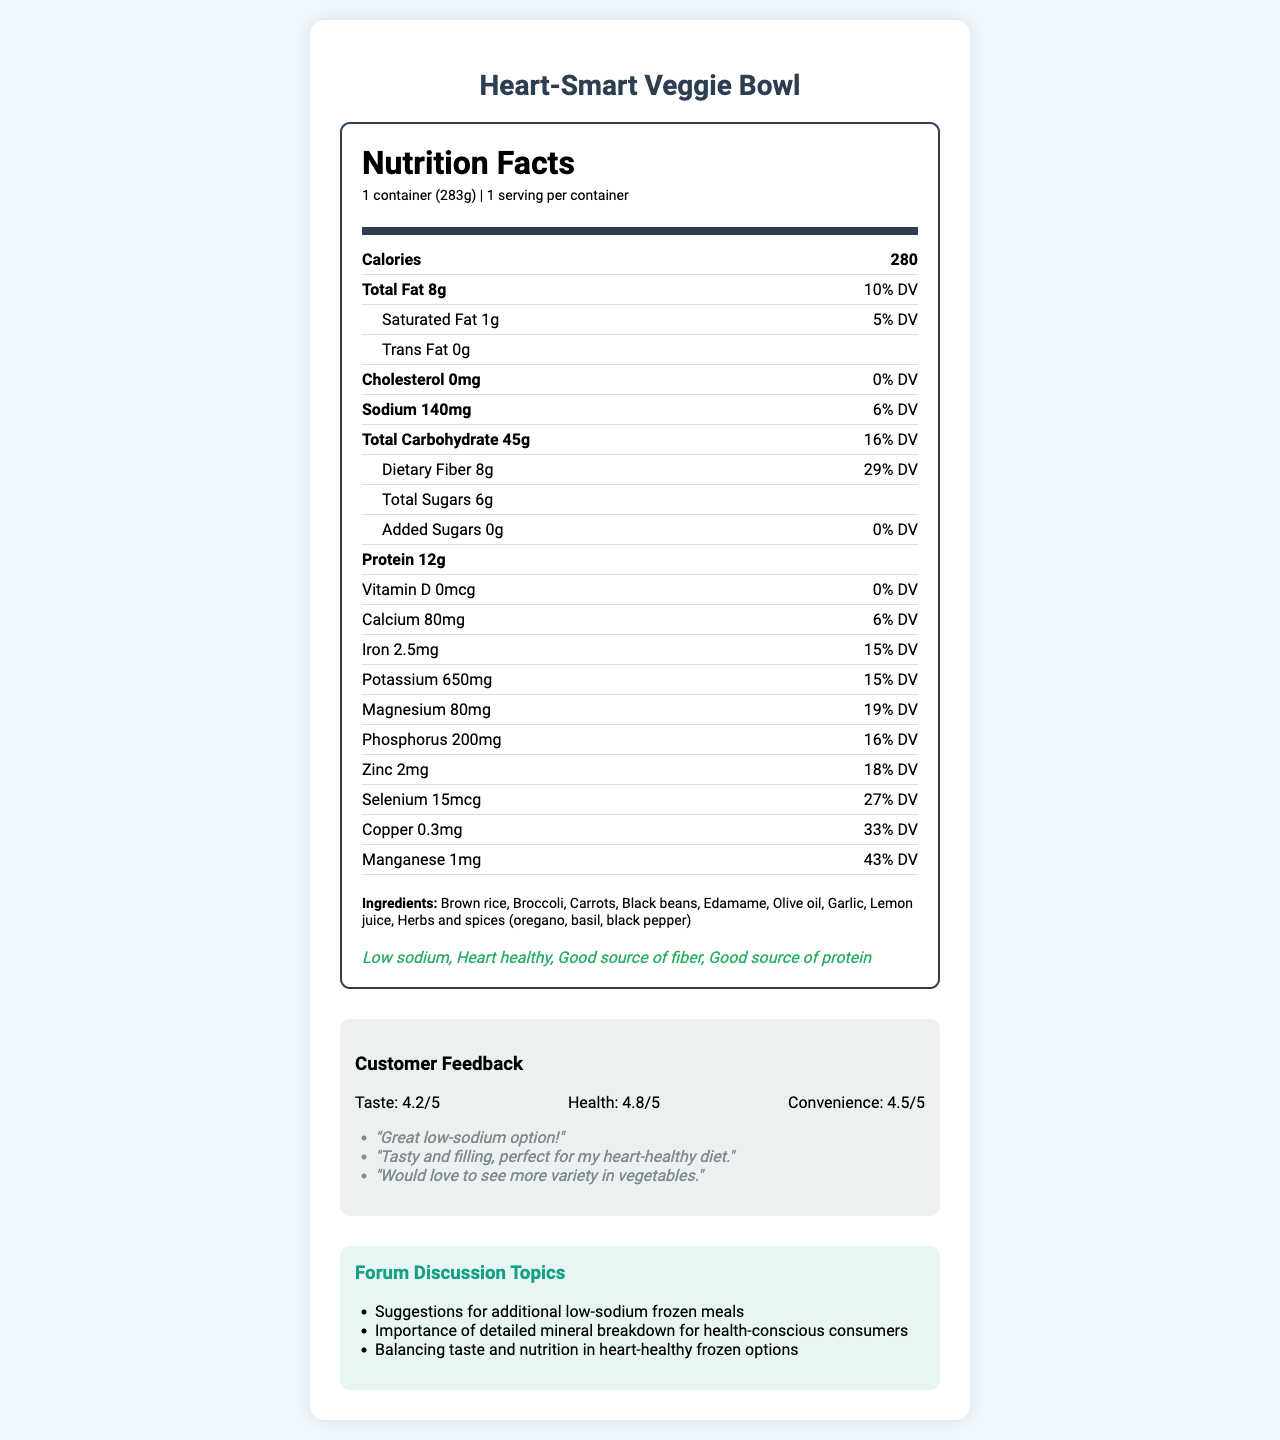what is the product name? The product name is listed at the top header of the document in larger, bold text.
Answer: Heart-Smart Veggie Bowl what is the serving size? The serving size information is found under the nutrition header, specifying both the serving size and the weight in grams.
Answer: 1 container (283g) how many calories are in one serving? The number of calories is prominently displayed under the nutrition header in a bold font.
Answer: 280 how much total fat is there in the meal? The total fat is listed under the nutrient rows with a bold label "Total Fat."
Answer: 8g how much sodium is in the meal? The sodium content is listed under the nutrient rows along with its daily value percentage.
Answer: 140mg how much dietary fiber does the meal contain? The amount of dietary fiber is specified as a sub-nutrient under Total Carbohydrate.
Answer: 8g what are the primary allergens present in the meal? The allergen information indicates that soy is present in the meal.
Answer: Soy Describe the customer feedback for the Heart-Smart Veggie Bowl. This is a summary of the customer feedback section, including ratings and verbatim comments.
Answer: The customer feedback shows that the product has a taste rating of 4.2/5, a health rating of 4.8/5, and a convenience rating of 4.5/5. Comments mention the product as a great low-sodium option, tasty and filling, but some customers would like to see more vegetable variety. which of the following is NOT a health claim made on the package? A. Low sodium B. High in sugar C. Good source of fiber D. Heart healthy The health claims section includes "Low sodium", "Heart healthy", and "Good source of fiber". "High in sugar" is not listed.
Answer: B Which ingredient is NOT part of the Heart-Smart Veggie Bowl? A. Olive oil B. Lemon juice C. Chicken D. Garlic The ingredient list includes Olive oil, Lemon juice, and Garlic. Chicken is not listed as an ingredient.
Answer: C Is the Heart-Smart Veggie Bowl suitable for a low-cholesterol diet? The nutrition label indicates the meal contains 0mg of cholesterol, making it suitable for a low-cholesterol diet.
Answer: Yes Does the document specify the total sugars in the meal? The total sugars are listed as 6g in the nutrient rows under Total Carbohydrate.
Answer: Yes Could you determine how many total vitamins are detailed in the document? The document provides detailed mineral breakdowns but does not enumerate any specific vitamins apart from vitamin D.
Answer: No How much Zinc does the Heart-Smart Veggie Bowl contain? The amount of Zinc is one of the mineral details listed in mg along with its daily value percentage.
Answer: 2mg Summarize the minerals included in the nutrition label. The summary includes a list of all minerals and their quantified amounts as given in the nutrition label section.
Answer: The nutrition label details the following minerals: Calcium (80mg), Iron (2.5mg), Potassium (650mg), Magnesium (80mg), Phosphorus (200mg), Zinc (2mg), Selenium (15mcg), Copper (0.3mg), and Manganese (1mg). 